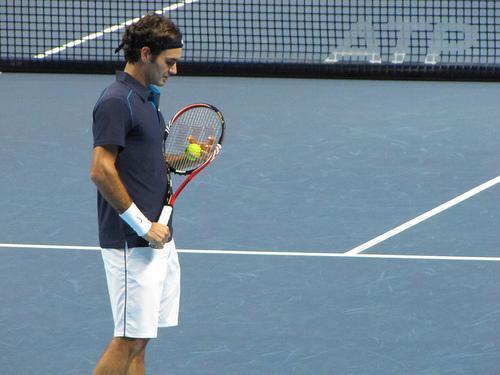How many people are shown?
Give a very brief answer. 1. 